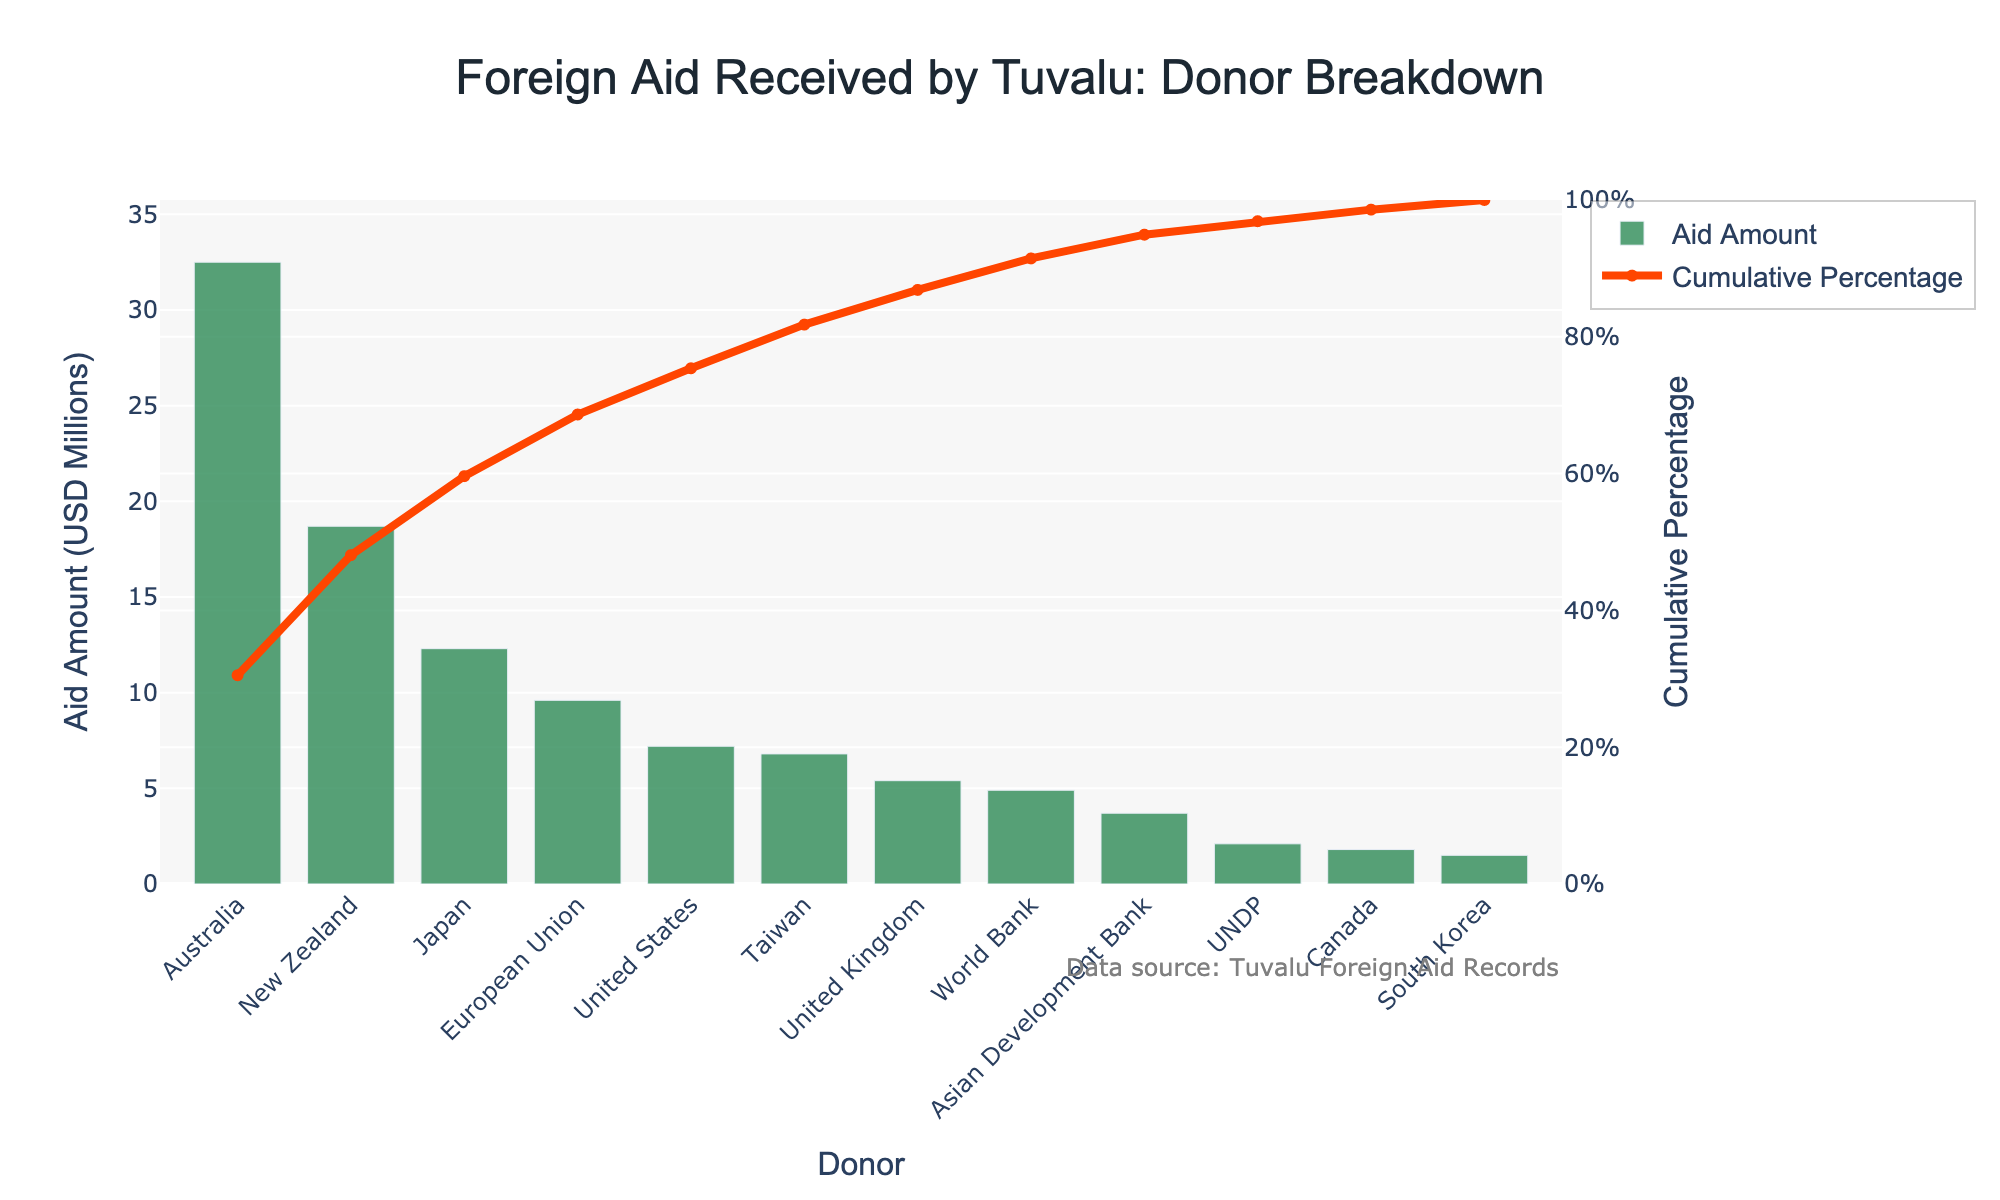What is the title of the chart? The title is placed at the top of the chart and typically gives a clear idea of what the chart represents. In this case, the title is in bold and large font.
Answer: Foreign Aid Received by Tuvalu: Donor Breakdown Which donor provided the highest amount of aid to Tuvalu? The highest bar represents the highest aid amount. The donor corresponding to this bar provides the highest aid.
Answer: Australia What is the Cumulative Percentage for aid received from Japan? The cumulative percentage line (in red) is annotated at each donor mark. Locate Japan on the x-axis and follow vertically to the red line to find its cumulative percentage.
Answer: 72.0% What is the total aid amount received from New Zealand and Japan combined? Find the aid amount for New Zealand and Japan from the bars, then add them together. New Zealand: 18.7, Japan: 12.3. Add both.
Answer: 31.0 million USD How many donors provided less than 5 million USD in aid? Look for bars with values below 5 million on the y-axis and count the number of these bars. UNDP, Canada, and South Korea are below 5 million.
Answer: 3 donors Which donor's aid amount brings the cumulative percentage close to 90%? Follow the cumulative percentage line close to 90% on the y-axis, then check the corresponding donor on the x-axis. Taiwain is just below 90%.
Answer: United Kingdom How does aid from the United States compare to that from Taiwan? Compare the heights of the bars for the United States and Taiwan to determine which is greater.
Answer: United States has more aid than Taiwan If 50% of the aid comes from the top two donors, which are they? Calculate the total aid and find 50% of this amount. Sum the aid amounts from the largest donors until reaching at least 50%. Australia (32.5) and New Zealand (18.7) combined are over 50%.
Answer: Australia and New Zealand What is the cumulative percentage after including aid from the European Union? Follow the cumulative percentage line at the European Union mark on the x-axis.
Answer: 84.7% What is the average aid amount received from the listed donors? Sum all individual aid amounts and divide by the total number of donors (12). Total aid: 106.5 million, divide by 12.
Answer: 8.875 million USD 